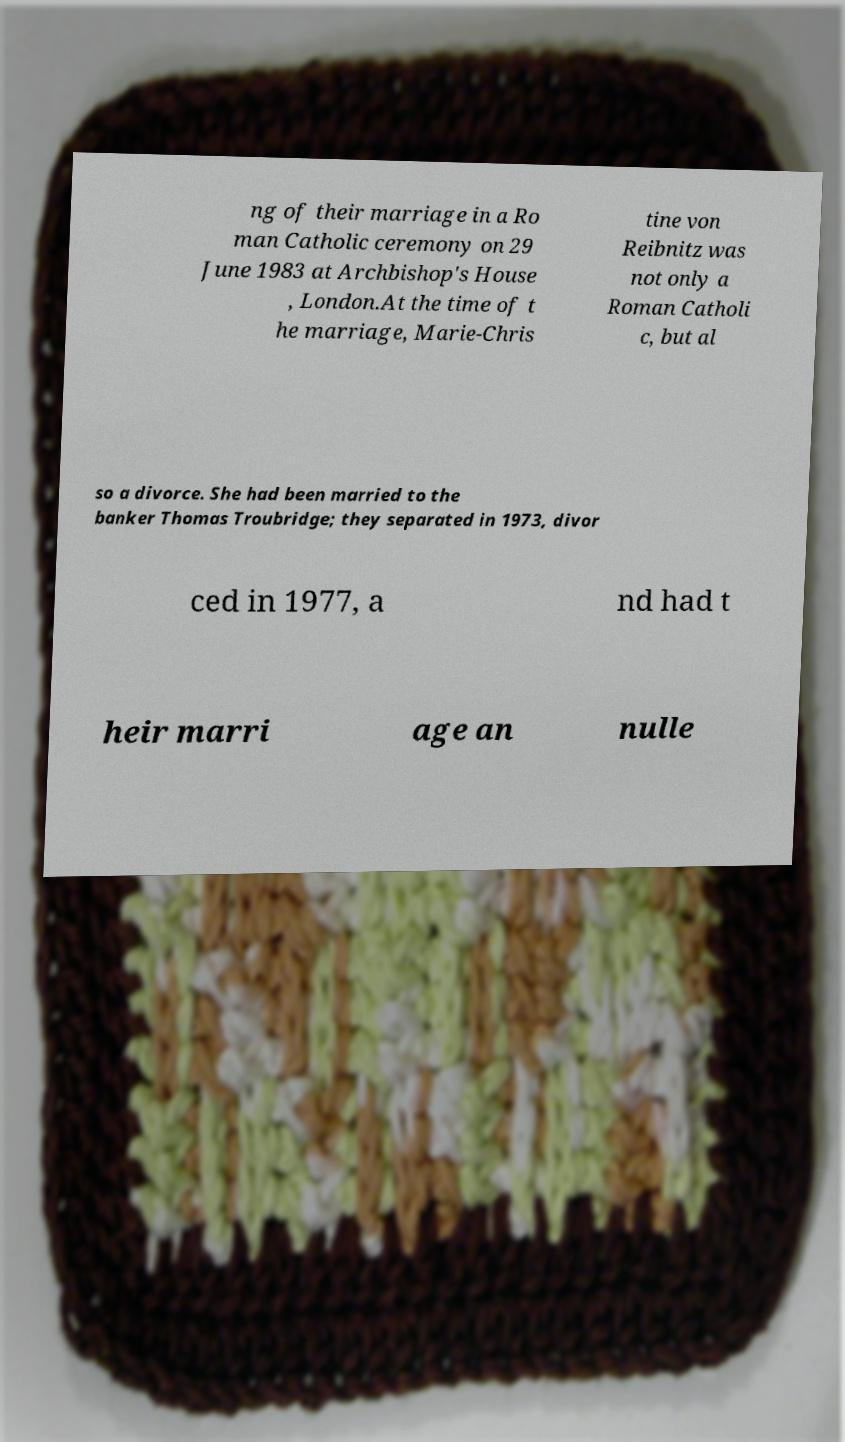There's text embedded in this image that I need extracted. Can you transcribe it verbatim? ng of their marriage in a Ro man Catholic ceremony on 29 June 1983 at Archbishop's House , London.At the time of t he marriage, Marie-Chris tine von Reibnitz was not only a Roman Catholi c, but al so a divorce. She had been married to the banker Thomas Troubridge; they separated in 1973, divor ced in 1977, a nd had t heir marri age an nulle 